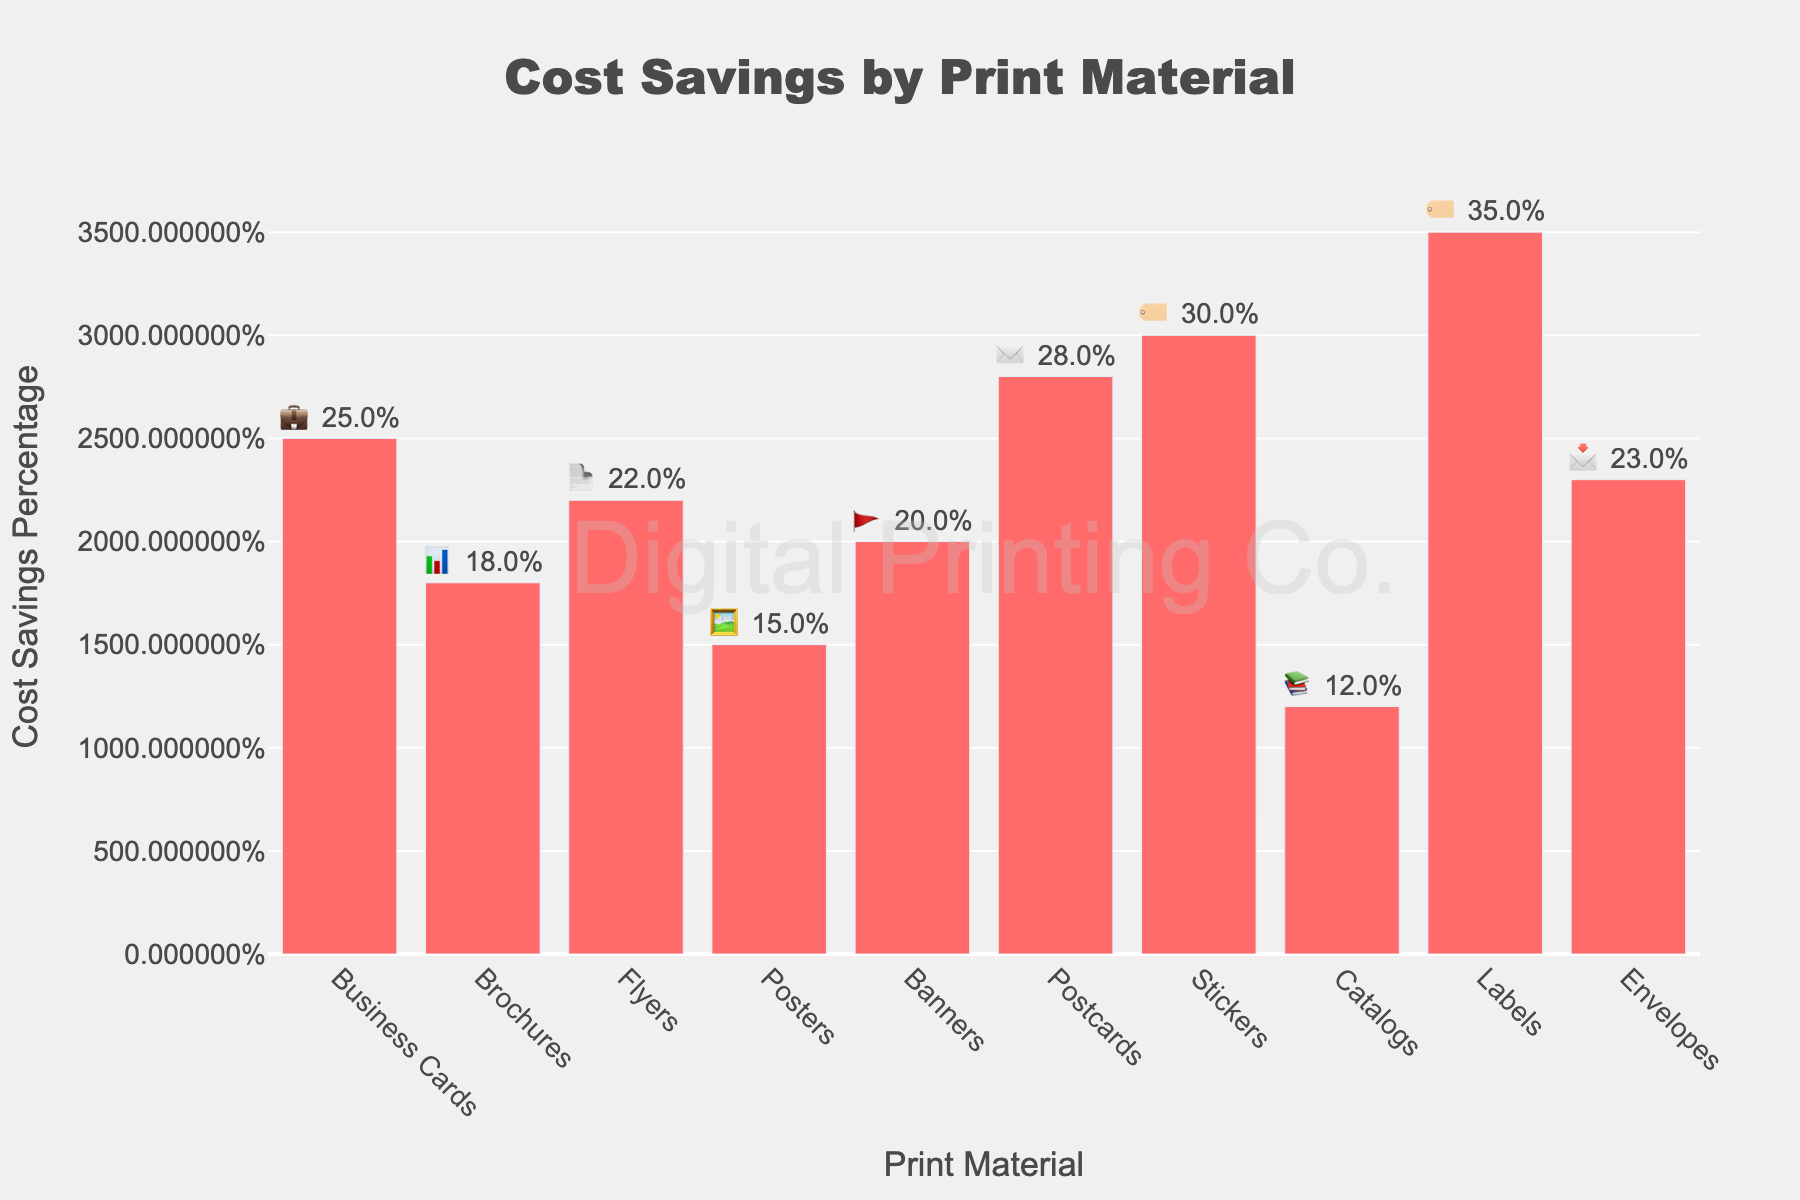What is the highest cost savings percentage for any print material? Look for the bar that reaches the highest on the y-axis. The highest savings are shown with the emoji for labels: 🏷️ at 35%.
Answer: 35% Which print material has the lowest cost savings percentage? Look for the shortest bar on the y-axis. Catalogs have the emoji 📚 and show the lowest value at 12%.
Answer: Catalogs What is the total cost savings of Flyers and Posters combined? Flyers save 22% (📄) and Posters save 15% (🖼️). The sum is 22% + 15% = 37%.
Answer: 37% How much more do Labels save compared to Business Cards? Labels save 35% (🏷️) and Business Cards save 25% (💼). The difference is 35% - 25% = 10%.
Answer: 10% Which print material offers the second highest cost savings? Look for the second tallest bar. The second tallest bar shows Stickers with 30% (🏷️).
Answer: Stickers How do the savings of Postcards compare to that of Flyers? Postcards save 28% (✉️) while Flyers save 22% (📄). 28% is greater than 22% by 6%.
Answer: Postcards save 6% more Which print materials have a cost savings percentage greater than or equal to 20%? Identify all bars with values 20% and above. These are Business Cards (25% 💼), Flyers (22% 📄), Banners (20% 🚩), Postcards (28% ✉️), Stickers (30% 🏷️), Labels (35% 🏷️), and Envelopes (23% 📩).
Answer: Business Cards, Flyers, Banners, Postcards, Stickers, Labels, Envelopes What is the median cost savings percentage across all print materials? Arrange the percentages in numerical order: 12%, 15%, 18%, 20%, 22%, 23%, 25%, 28%, 30%, 35%. The median of these 10 values is the average of the 5th and 6th values: (22% + 23%) / 2 = 22.5%.
Answer: 22.5% How much do Business Cards and Flyers save together compared to Brochures? Business Cards save 25% (💼) and Flyers save 22% (📄), totaling 47%. Brochures save 18% (📊), so the difference is 47% - 18% = 29%.
Answer: 29% What print material has a cost savings just above Catalogs? Catalogs save 12% (📚). The next bar up is Posters at 15% (🖼️).
Answer: Posters 